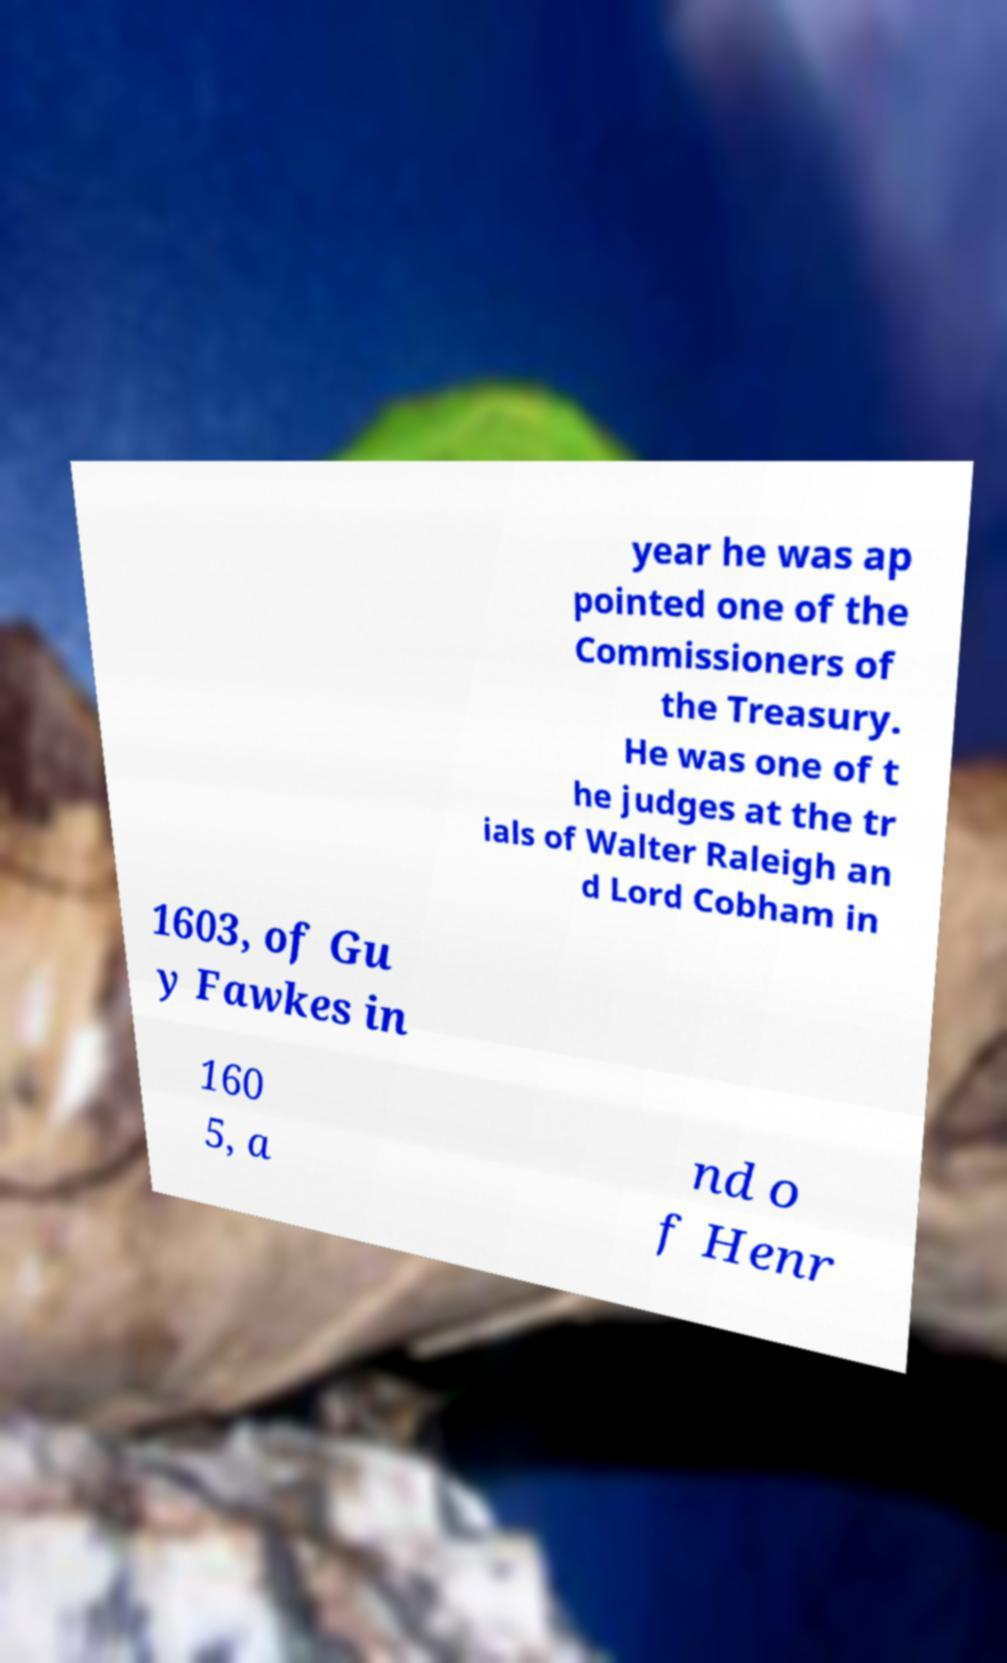There's text embedded in this image that I need extracted. Can you transcribe it verbatim? year he was ap pointed one of the Commissioners of the Treasury. He was one of t he judges at the tr ials of Walter Raleigh an d Lord Cobham in 1603, of Gu y Fawkes in 160 5, a nd o f Henr 